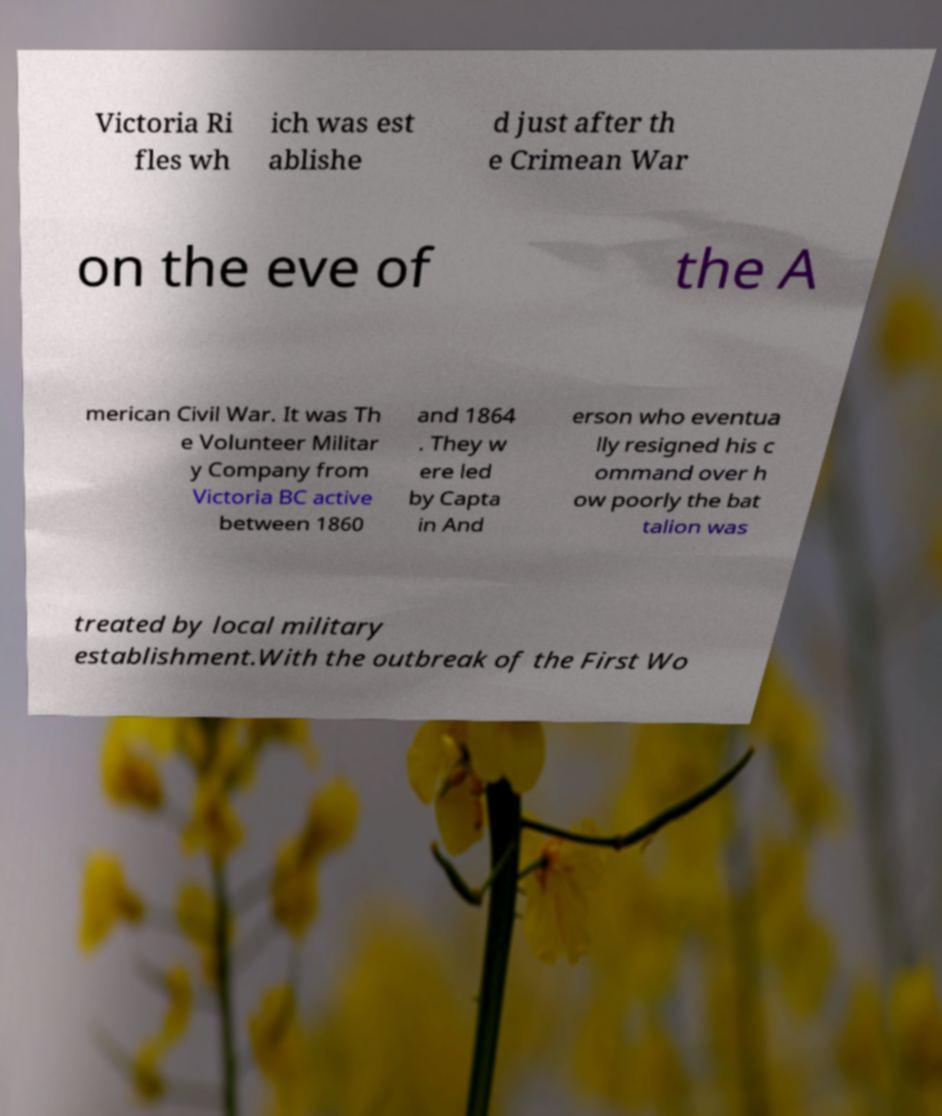Can you read and provide the text displayed in the image?This photo seems to have some interesting text. Can you extract and type it out for me? Victoria Ri fles wh ich was est ablishe d just after th e Crimean War on the eve of the A merican Civil War. It was Th e Volunteer Militar y Company from Victoria BC active between 1860 and 1864 . They w ere led by Capta in And erson who eventua lly resigned his c ommand over h ow poorly the bat talion was treated by local military establishment.With the outbreak of the First Wo 